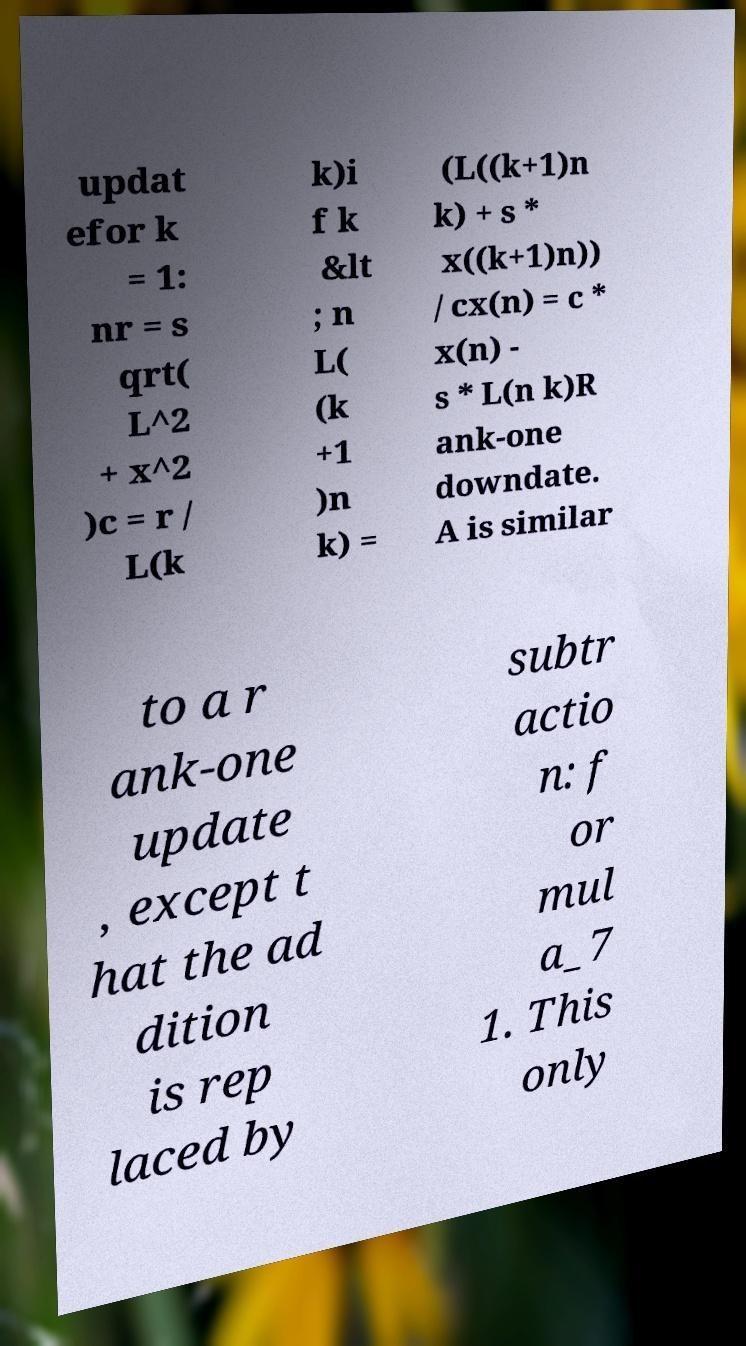I need the written content from this picture converted into text. Can you do that? updat efor k = 1: nr = s qrt( L^2 + x^2 )c = r / L(k k)i f k &lt ; n L( (k +1 )n k) = (L((k+1)n k) + s * x((k+1)n)) / cx(n) = c * x(n) - s * L(n k)R ank-one downdate. A is similar to a r ank-one update , except t hat the ad dition is rep laced by subtr actio n: f or mul a_7 1. This only 